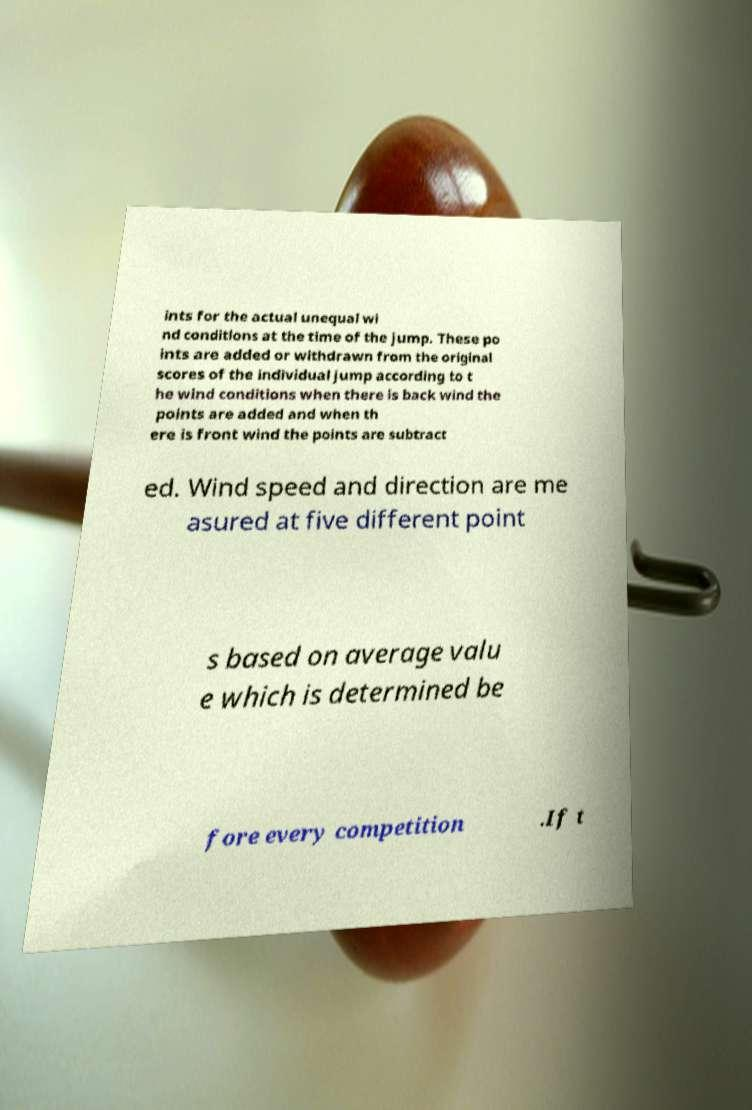Please identify and transcribe the text found in this image. ints for the actual unequal wi nd conditions at the time of the jump. These po ints are added or withdrawn from the original scores of the individual jump according to t he wind conditions when there is back wind the points are added and when th ere is front wind the points are subtract ed. Wind speed and direction are me asured at five different point s based on average valu e which is determined be fore every competition .If t 